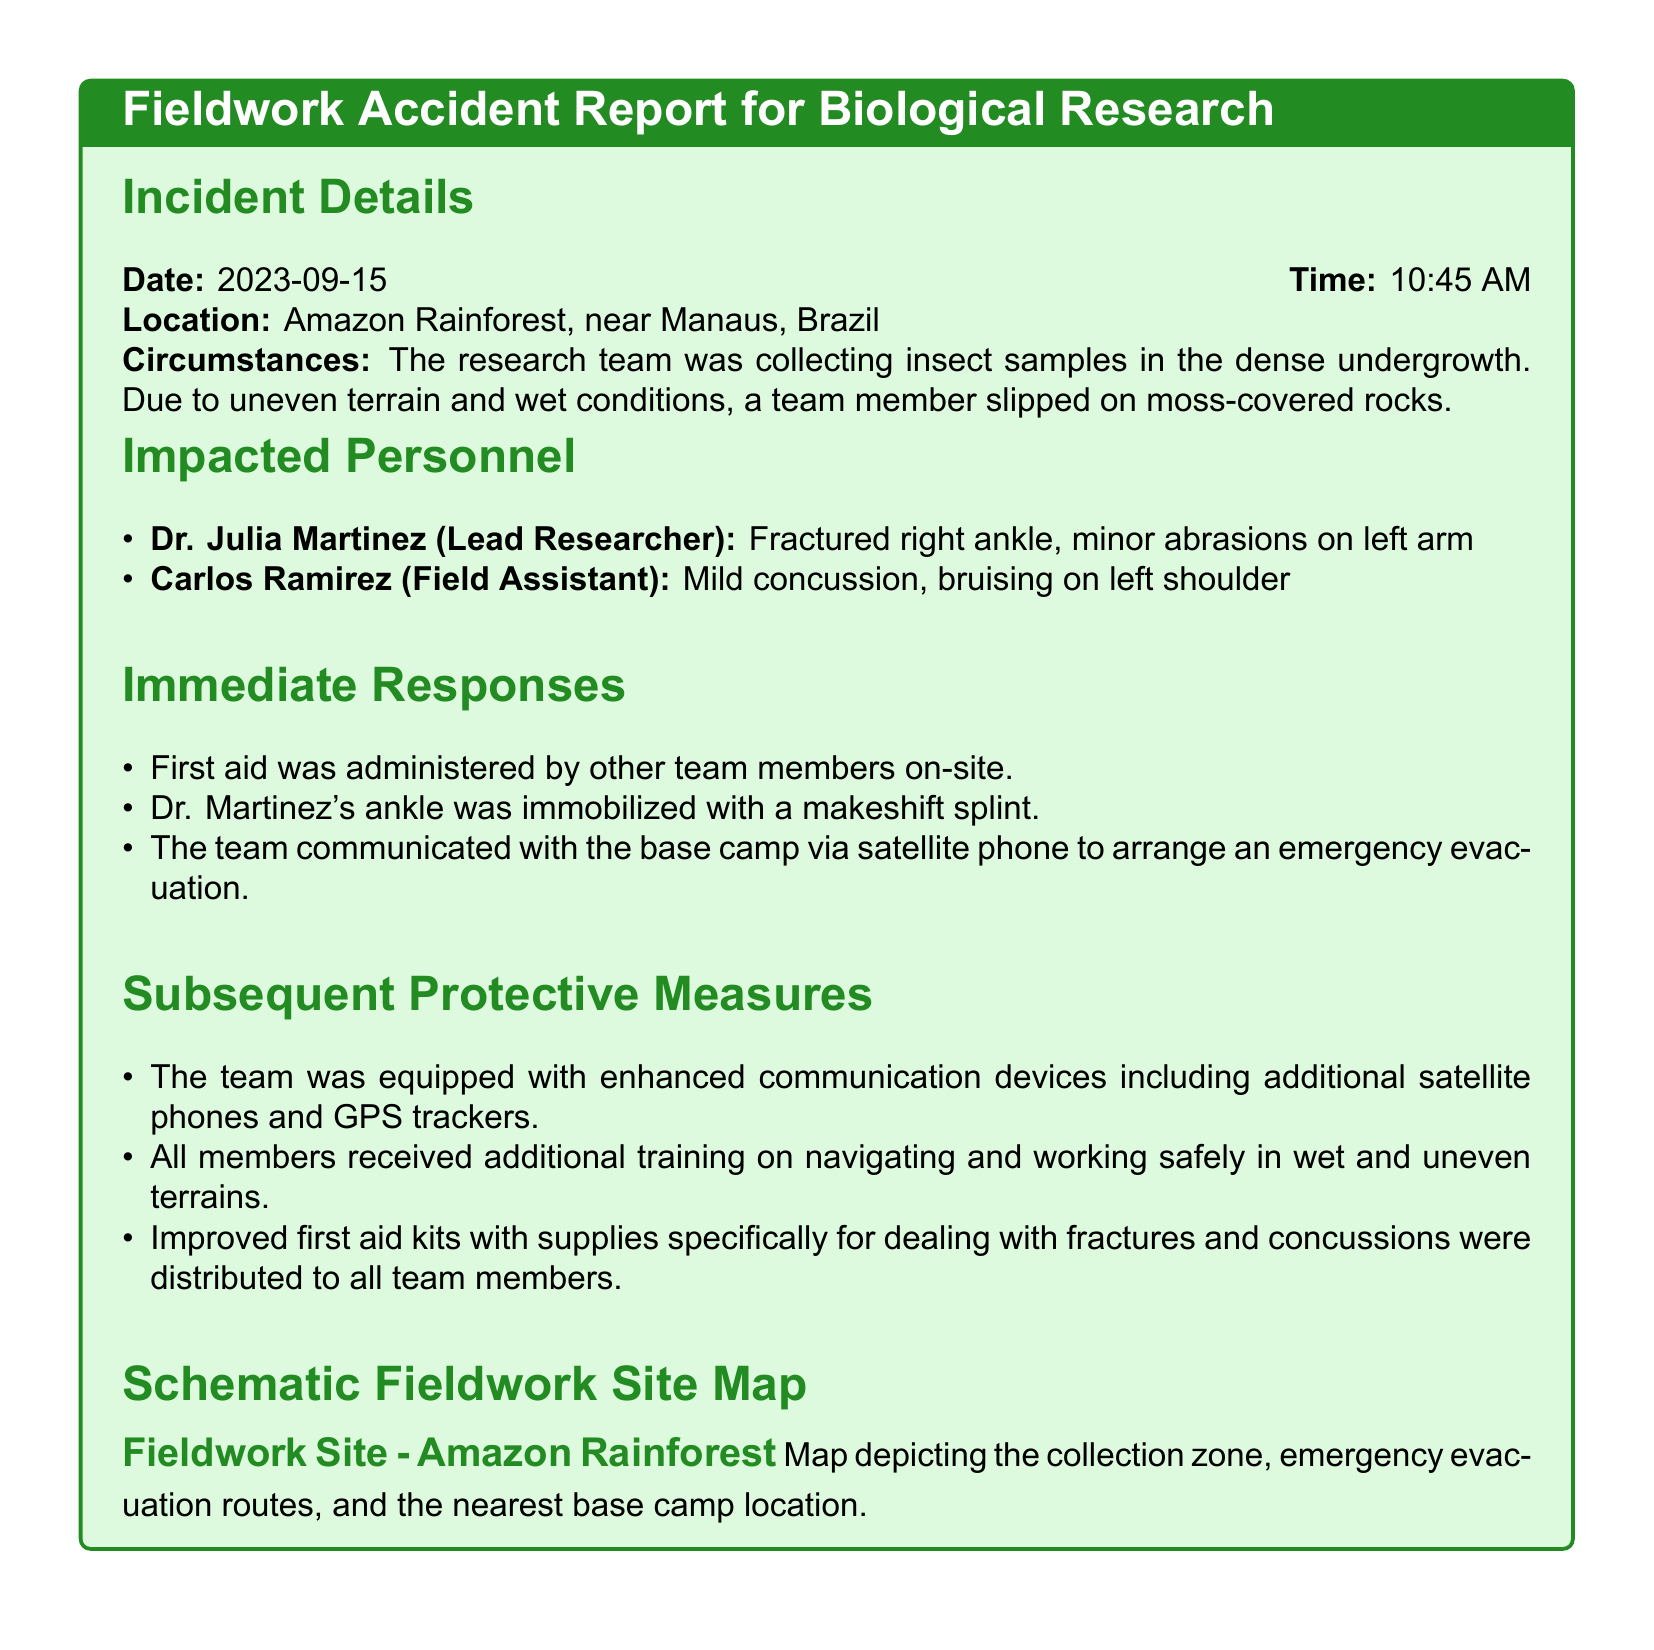What was the date of the incident? The date is mentioned in the Incident Details section of the report.
Answer: 2023-09-15 Who was the lead researcher involved in the incident? The Lead Researcher is listed in the Impacted Personnel section.
Answer: Dr. Julia Martinez What injury did Carlos Ramirez sustain? The injury is specified in the Impacted Personnel section.
Answer: Mild concussion What immediate action was taken for Dr. Martinez's injury? The response to her injury is detailed in the Immediate Responses section.
Answer: Ankle was immobilized What protective measure was implemented related to communication? This information is found in the Subsequent Protective Measures section.
Answer: Enhanced communication devices How many personnel were impacted by the accident? The number can be counted from the Impacted Personnel section.
Answer: Two What was the time of the incident? The time is stated in the Incident Details section.
Answer: 10:45 AM What training did team members receive after the incident? The type of training is outlined in the Subsequent Protective Measures section.
Answer: Navigating and working safely in wet and uneven terrains What type of map is included in the report? This is described under the Schematic Fieldwork Site Map section.
Answer: Fieldwork Site Map 